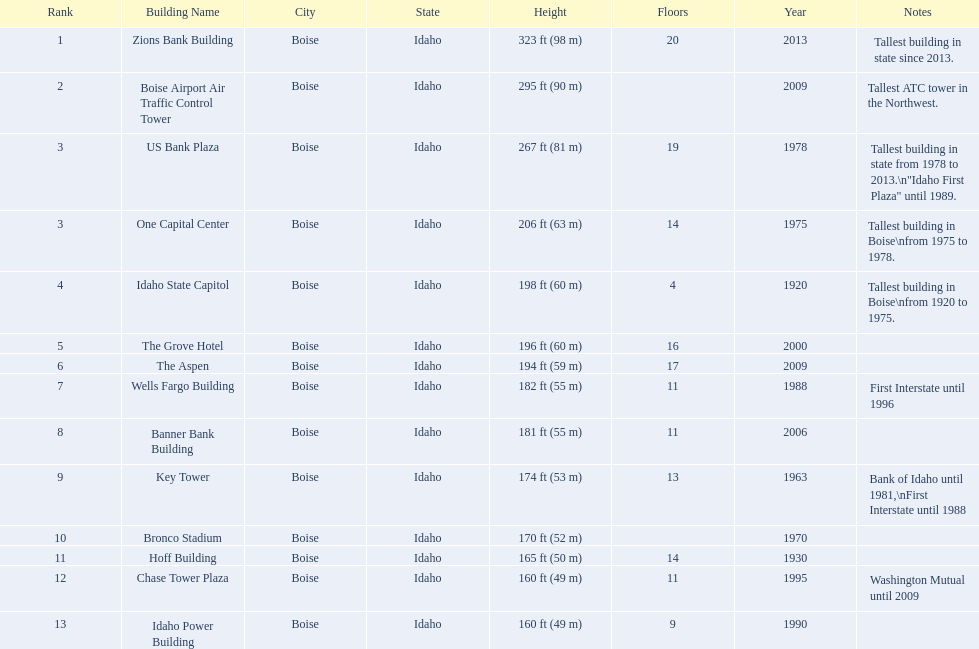Is the bronco stadium above or below 150 ft? Above. 